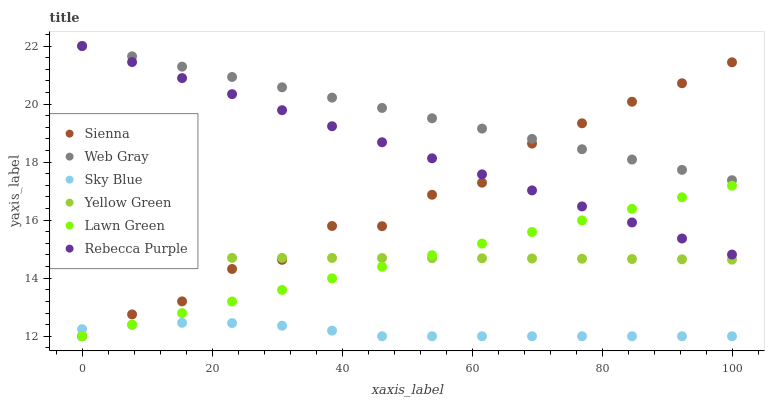Does Sky Blue have the minimum area under the curve?
Answer yes or no. Yes. Does Web Gray have the maximum area under the curve?
Answer yes or no. Yes. Does Yellow Green have the minimum area under the curve?
Answer yes or no. No. Does Yellow Green have the maximum area under the curve?
Answer yes or no. No. Is Lawn Green the smoothest?
Answer yes or no. Yes. Is Sienna the roughest?
Answer yes or no. Yes. Is Web Gray the smoothest?
Answer yes or no. No. Is Web Gray the roughest?
Answer yes or no. No. Does Lawn Green have the lowest value?
Answer yes or no. Yes. Does Yellow Green have the lowest value?
Answer yes or no. No. Does Rebecca Purple have the highest value?
Answer yes or no. Yes. Does Yellow Green have the highest value?
Answer yes or no. No. Is Sky Blue less than Yellow Green?
Answer yes or no. Yes. Is Web Gray greater than Yellow Green?
Answer yes or no. Yes. Does Sky Blue intersect Sienna?
Answer yes or no. Yes. Is Sky Blue less than Sienna?
Answer yes or no. No. Is Sky Blue greater than Sienna?
Answer yes or no. No. Does Sky Blue intersect Yellow Green?
Answer yes or no. No. 